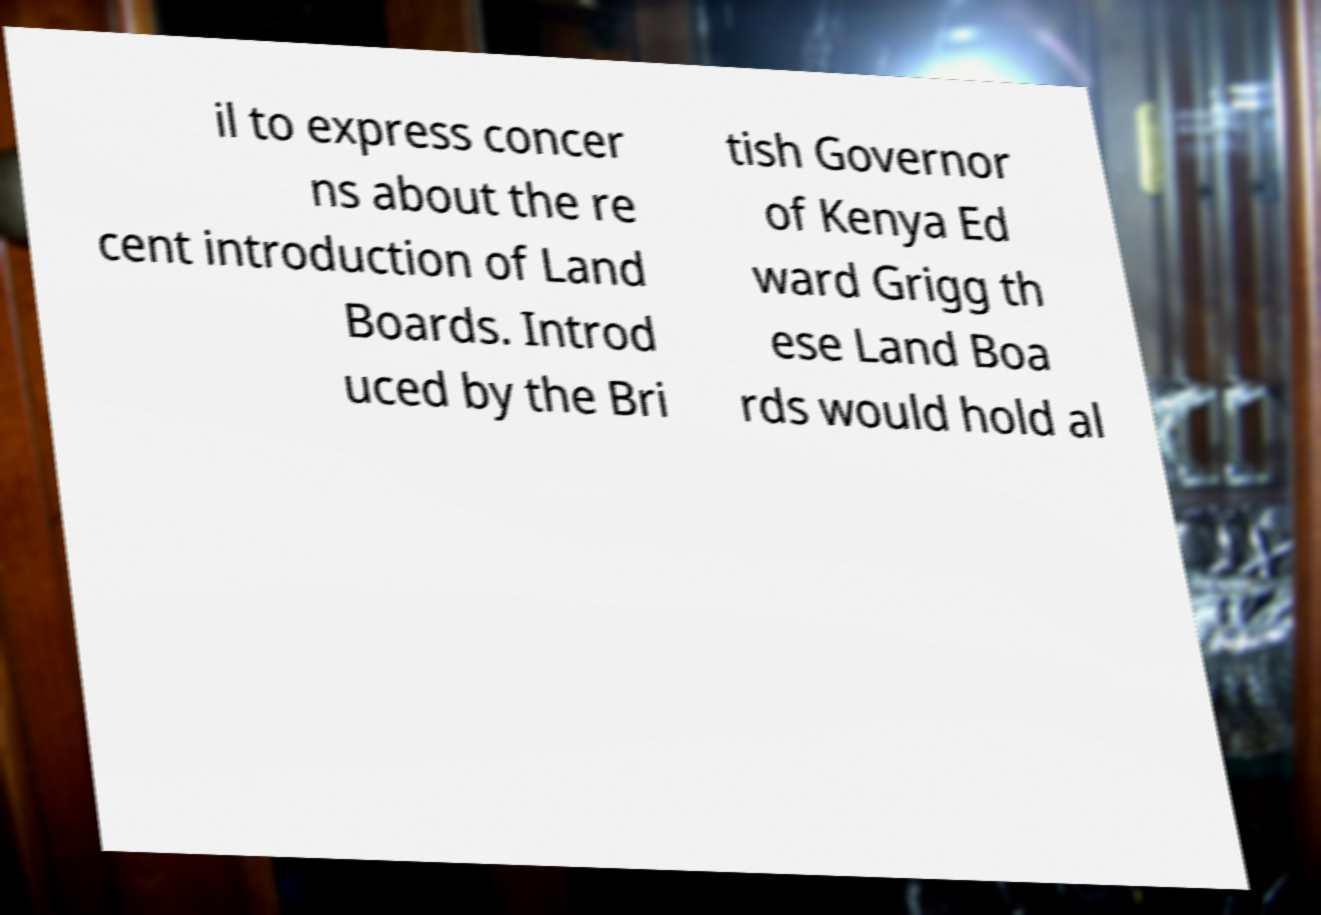Could you extract and type out the text from this image? il to express concer ns about the re cent introduction of Land Boards. Introd uced by the Bri tish Governor of Kenya Ed ward Grigg th ese Land Boa rds would hold al 